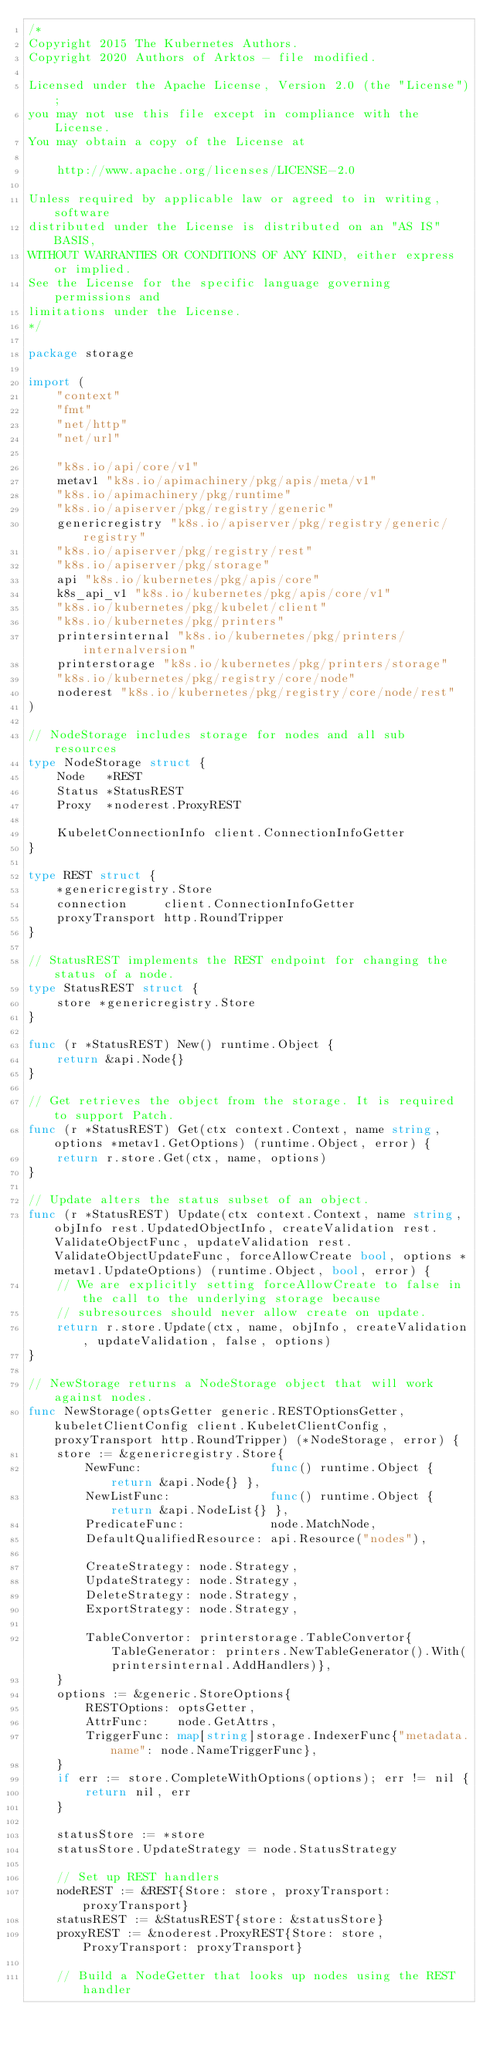Convert code to text. <code><loc_0><loc_0><loc_500><loc_500><_Go_>/*
Copyright 2015 The Kubernetes Authors.
Copyright 2020 Authors of Arktos - file modified.

Licensed under the Apache License, Version 2.0 (the "License");
you may not use this file except in compliance with the License.
You may obtain a copy of the License at

    http://www.apache.org/licenses/LICENSE-2.0

Unless required by applicable law or agreed to in writing, software
distributed under the License is distributed on an "AS IS" BASIS,
WITHOUT WARRANTIES OR CONDITIONS OF ANY KIND, either express or implied.
See the License for the specific language governing permissions and
limitations under the License.
*/

package storage

import (
	"context"
	"fmt"
	"net/http"
	"net/url"

	"k8s.io/api/core/v1"
	metav1 "k8s.io/apimachinery/pkg/apis/meta/v1"
	"k8s.io/apimachinery/pkg/runtime"
	"k8s.io/apiserver/pkg/registry/generic"
	genericregistry "k8s.io/apiserver/pkg/registry/generic/registry"
	"k8s.io/apiserver/pkg/registry/rest"
	"k8s.io/apiserver/pkg/storage"
	api "k8s.io/kubernetes/pkg/apis/core"
	k8s_api_v1 "k8s.io/kubernetes/pkg/apis/core/v1"
	"k8s.io/kubernetes/pkg/kubelet/client"
	"k8s.io/kubernetes/pkg/printers"
	printersinternal "k8s.io/kubernetes/pkg/printers/internalversion"
	printerstorage "k8s.io/kubernetes/pkg/printers/storage"
	"k8s.io/kubernetes/pkg/registry/core/node"
	noderest "k8s.io/kubernetes/pkg/registry/core/node/rest"
)

// NodeStorage includes storage for nodes and all sub resources
type NodeStorage struct {
	Node   *REST
	Status *StatusREST
	Proxy  *noderest.ProxyREST

	KubeletConnectionInfo client.ConnectionInfoGetter
}

type REST struct {
	*genericregistry.Store
	connection     client.ConnectionInfoGetter
	proxyTransport http.RoundTripper
}

// StatusREST implements the REST endpoint for changing the status of a node.
type StatusREST struct {
	store *genericregistry.Store
}

func (r *StatusREST) New() runtime.Object {
	return &api.Node{}
}

// Get retrieves the object from the storage. It is required to support Patch.
func (r *StatusREST) Get(ctx context.Context, name string, options *metav1.GetOptions) (runtime.Object, error) {
	return r.store.Get(ctx, name, options)
}

// Update alters the status subset of an object.
func (r *StatusREST) Update(ctx context.Context, name string, objInfo rest.UpdatedObjectInfo, createValidation rest.ValidateObjectFunc, updateValidation rest.ValidateObjectUpdateFunc, forceAllowCreate bool, options *metav1.UpdateOptions) (runtime.Object, bool, error) {
	// We are explicitly setting forceAllowCreate to false in the call to the underlying storage because
	// subresources should never allow create on update.
	return r.store.Update(ctx, name, objInfo, createValidation, updateValidation, false, options)
}

// NewStorage returns a NodeStorage object that will work against nodes.
func NewStorage(optsGetter generic.RESTOptionsGetter, kubeletClientConfig client.KubeletClientConfig, proxyTransport http.RoundTripper) (*NodeStorage, error) {
	store := &genericregistry.Store{
		NewFunc:                  func() runtime.Object { return &api.Node{} },
		NewListFunc:              func() runtime.Object { return &api.NodeList{} },
		PredicateFunc:            node.MatchNode,
		DefaultQualifiedResource: api.Resource("nodes"),

		CreateStrategy: node.Strategy,
		UpdateStrategy: node.Strategy,
		DeleteStrategy: node.Strategy,
		ExportStrategy: node.Strategy,

		TableConvertor: printerstorage.TableConvertor{TableGenerator: printers.NewTableGenerator().With(printersinternal.AddHandlers)},
	}
	options := &generic.StoreOptions{
		RESTOptions: optsGetter,
		AttrFunc:    node.GetAttrs,
		TriggerFunc: map[string]storage.IndexerFunc{"metadata.name": node.NameTriggerFunc},
	}
	if err := store.CompleteWithOptions(options); err != nil {
		return nil, err
	}

	statusStore := *store
	statusStore.UpdateStrategy = node.StatusStrategy

	// Set up REST handlers
	nodeREST := &REST{Store: store, proxyTransport: proxyTransport}
	statusREST := &StatusREST{store: &statusStore}
	proxyREST := &noderest.ProxyREST{Store: store, ProxyTransport: proxyTransport}

	// Build a NodeGetter that looks up nodes using the REST handler</code> 